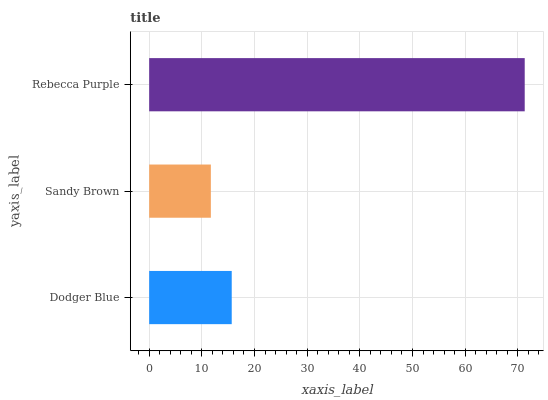Is Sandy Brown the minimum?
Answer yes or no. Yes. Is Rebecca Purple the maximum?
Answer yes or no. Yes. Is Rebecca Purple the minimum?
Answer yes or no. No. Is Sandy Brown the maximum?
Answer yes or no. No. Is Rebecca Purple greater than Sandy Brown?
Answer yes or no. Yes. Is Sandy Brown less than Rebecca Purple?
Answer yes or no. Yes. Is Sandy Brown greater than Rebecca Purple?
Answer yes or no. No. Is Rebecca Purple less than Sandy Brown?
Answer yes or no. No. Is Dodger Blue the high median?
Answer yes or no. Yes. Is Dodger Blue the low median?
Answer yes or no. Yes. Is Sandy Brown the high median?
Answer yes or no. No. Is Sandy Brown the low median?
Answer yes or no. No. 